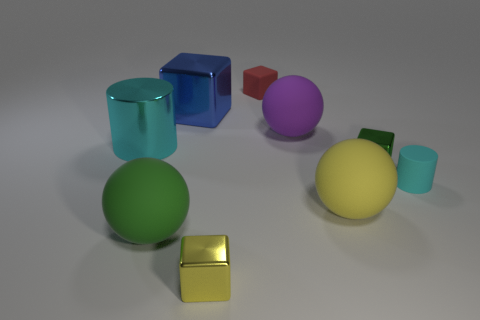How many things are either tiny cubes or spheres that are in front of the tiny cylinder?
Give a very brief answer. 5. Are there any cyan matte cylinders of the same size as the rubber cube?
Keep it short and to the point. Yes. Do the blue thing and the small red thing have the same material?
Your answer should be compact. No. How many objects are large yellow rubber objects or big shiny cylinders?
Give a very brief answer. 2. What is the size of the blue metal block?
Your response must be concise. Large. Are there fewer large blue blocks than large red rubber cylinders?
Give a very brief answer. No. What number of large cylinders have the same color as the tiny rubber cylinder?
Your response must be concise. 1. There is a shiny object in front of the cyan rubber thing; does it have the same color as the matte cube?
Offer a terse response. No. What shape is the green thing that is in front of the big yellow thing?
Ensure brevity in your answer.  Sphere. Are there any cyan objects to the left of the tiny metallic thing behind the green sphere?
Give a very brief answer. Yes. 